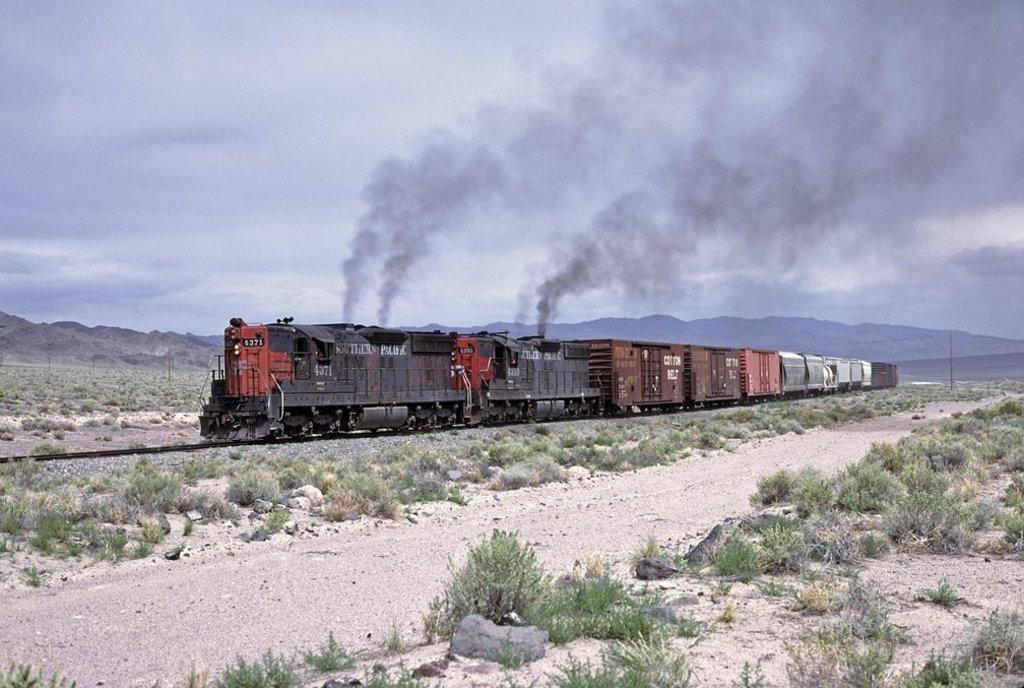Could you give a brief overview of what you see in this image? In this image we can see a train running on the track, there are some rocks, plants, bushes, we can also see the mountains, and the sky. 